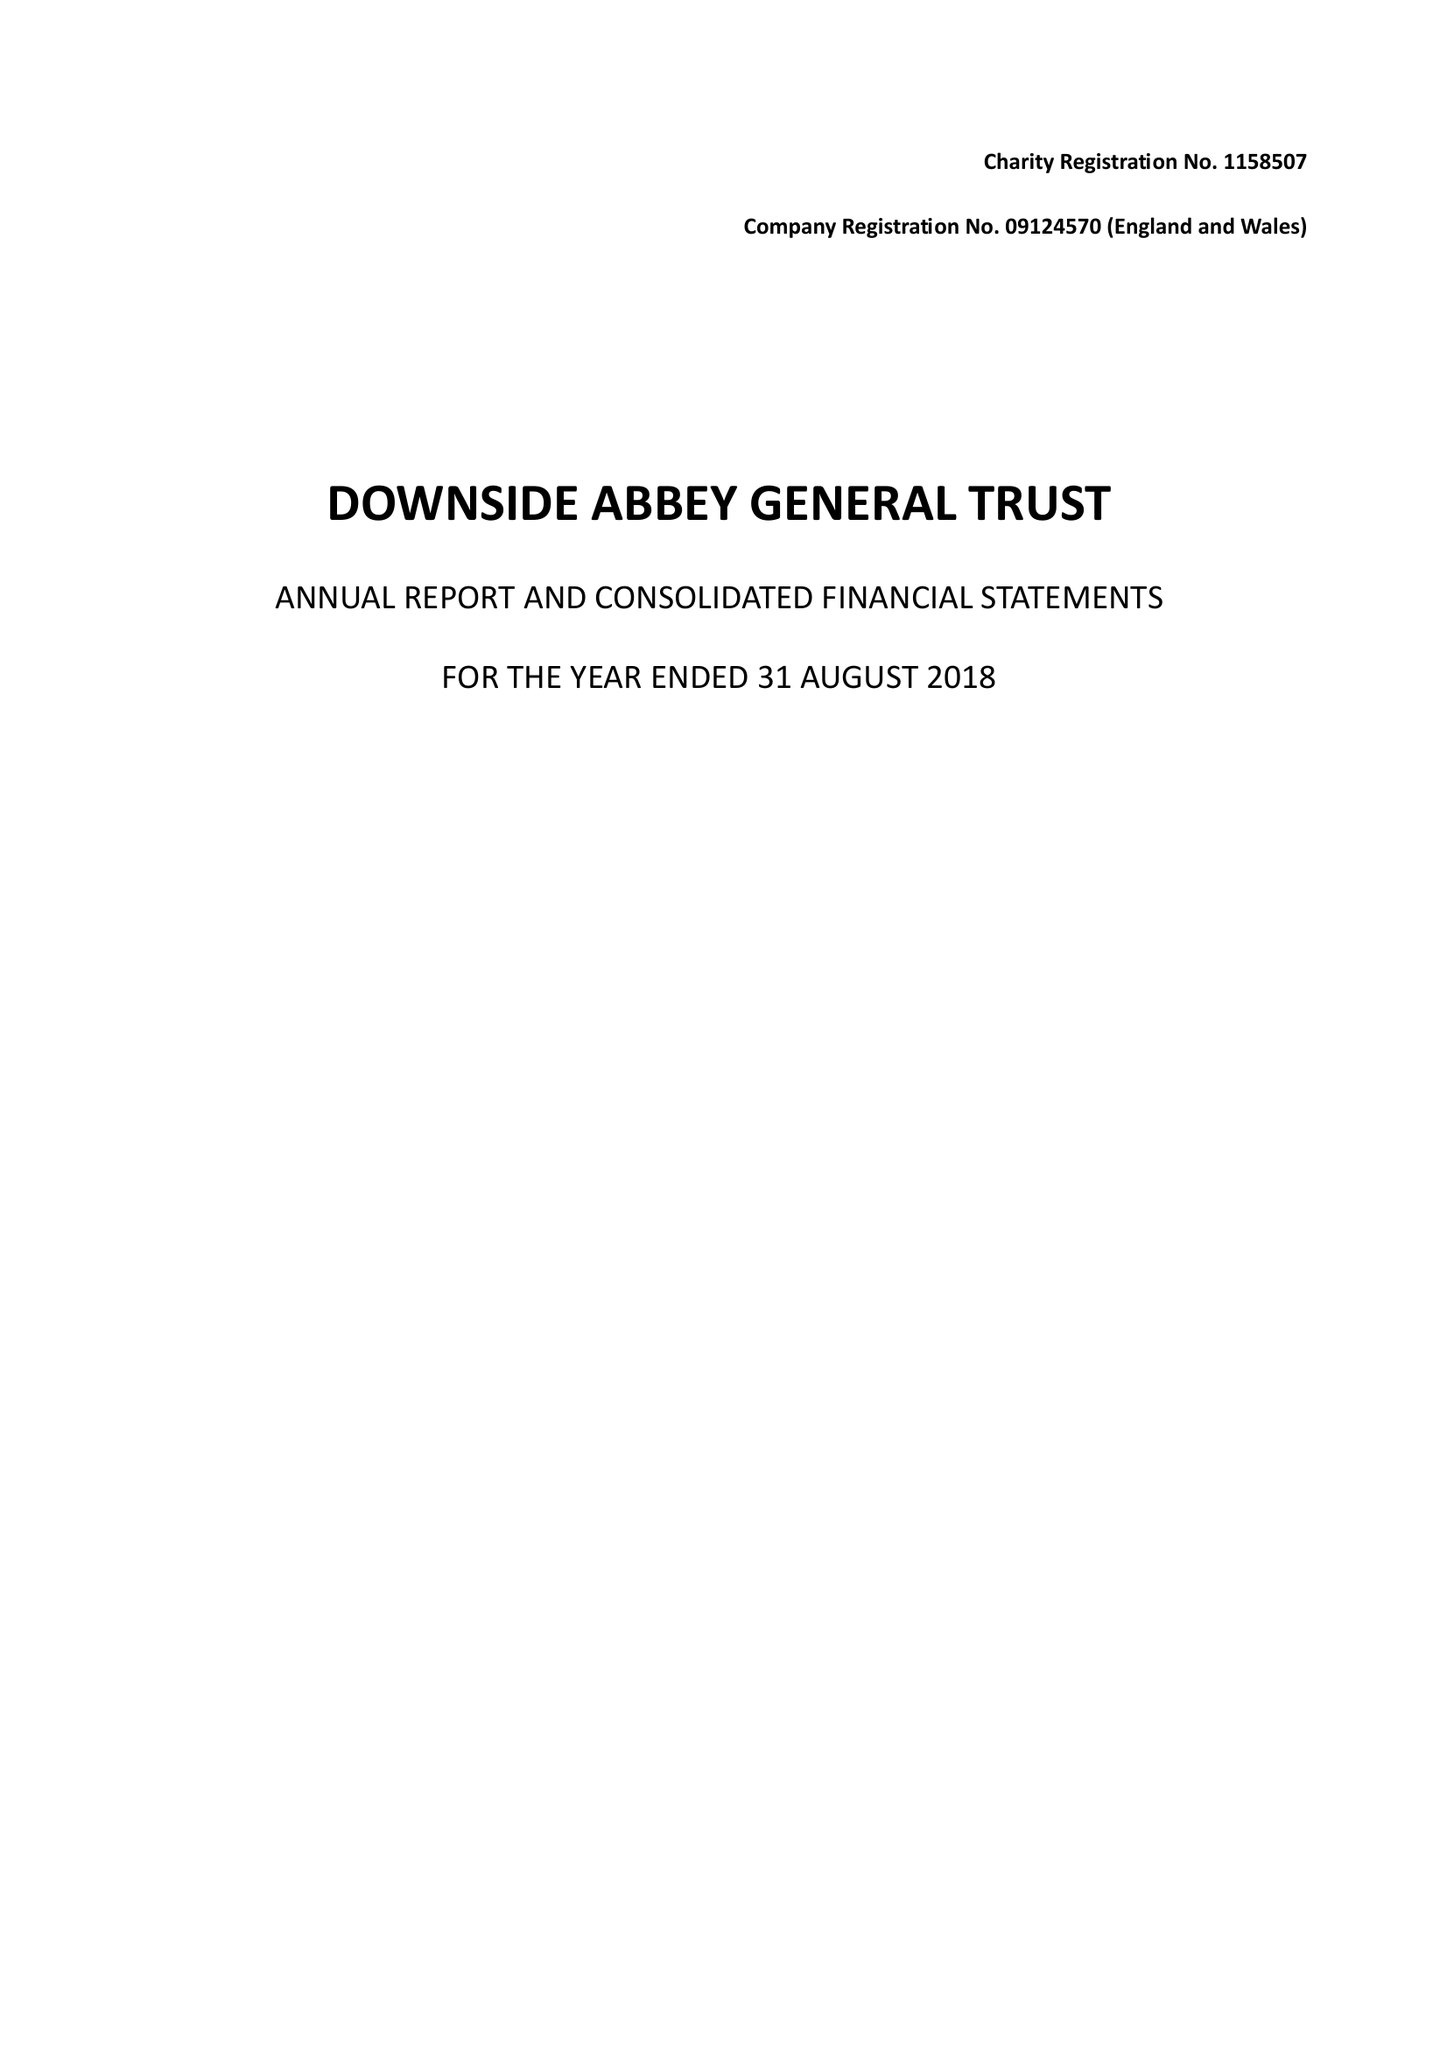What is the value for the address__postcode?
Answer the question using a single word or phrase. BA3 4RH 